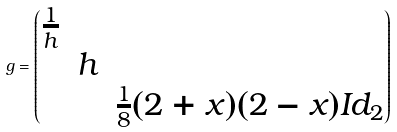<formula> <loc_0><loc_0><loc_500><loc_500>g = \begin{pmatrix} \frac { 1 } { h } & & \\ & h & \\ & & \frac { 1 } { 8 } ( 2 + x ) ( 2 - x ) I d _ { 2 } \\ \end{pmatrix}</formula> 